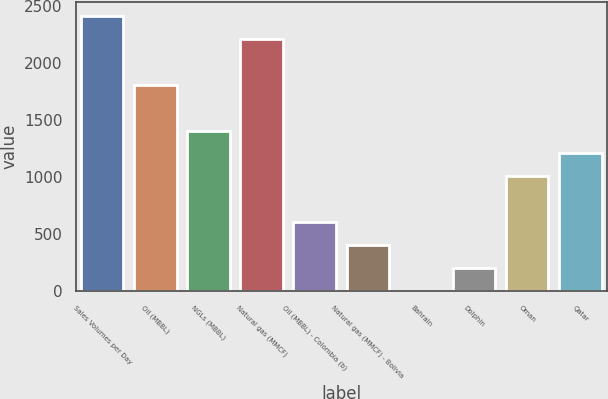Convert chart to OTSL. <chart><loc_0><loc_0><loc_500><loc_500><bar_chart><fcel>Sales Volumes per Day<fcel>Oil (MBBL)<fcel>NGLs (MBBL)<fcel>Natural gas (MMCF)<fcel>Oil (MBBL) - Colombia (b)<fcel>Natural gas (MMCF) - Bolivia<fcel>Bahrain<fcel>Dolphin<fcel>Oman<fcel>Qatar<nl><fcel>2413.6<fcel>1811.2<fcel>1409.6<fcel>2212.8<fcel>606.4<fcel>405.6<fcel>4<fcel>204.8<fcel>1008<fcel>1208.8<nl></chart> 